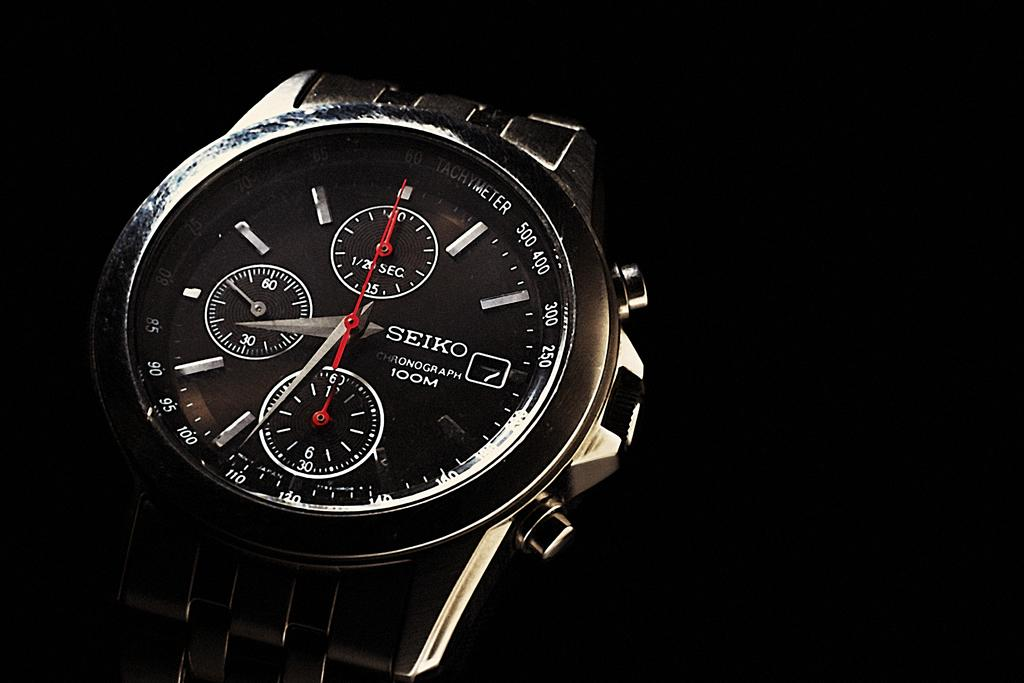What object is the main subject of the image? There is a wrist watch in the image. What colors can be seen on the wrist watch? The wrist watch is black, white, and red in color. What is the color of the background in the image? The background of the image is black. How many feet does the friend have in the image? There is no friend or feet present in the image; it only features a wrist watch. 